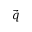Convert formula to latex. <formula><loc_0><loc_0><loc_500><loc_500>\vec { q }</formula> 